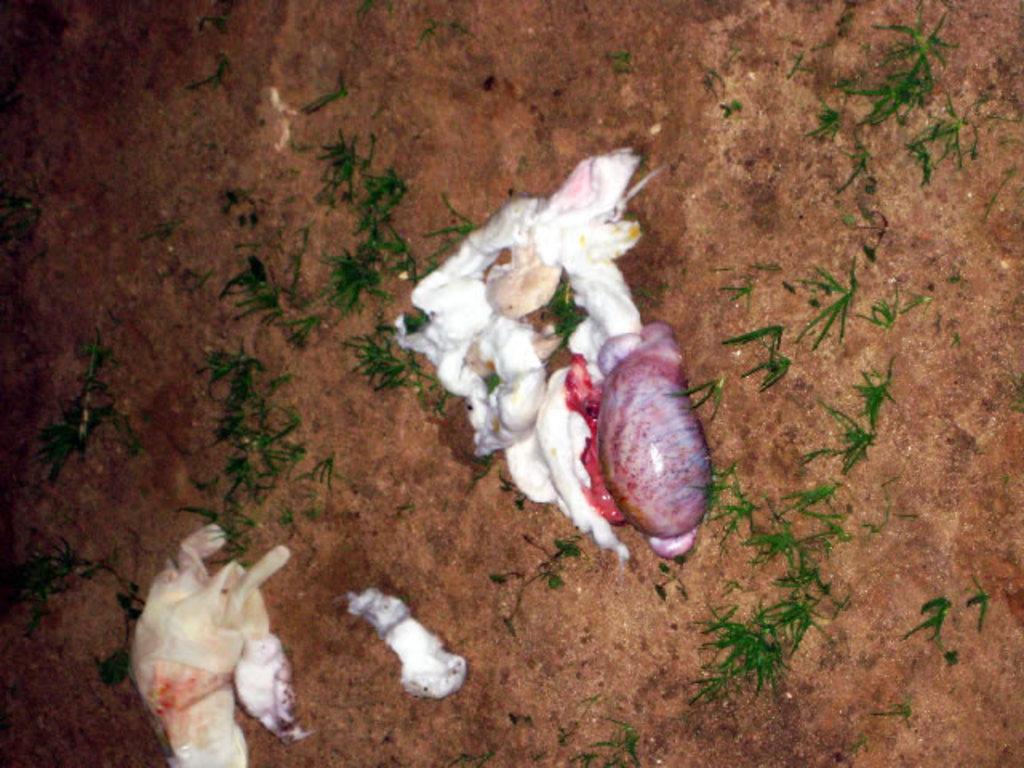In one or two sentences, can you explain what this image depicts? In this picture we can see cotton and other objects on the ground. On the right we can see the green grass. 